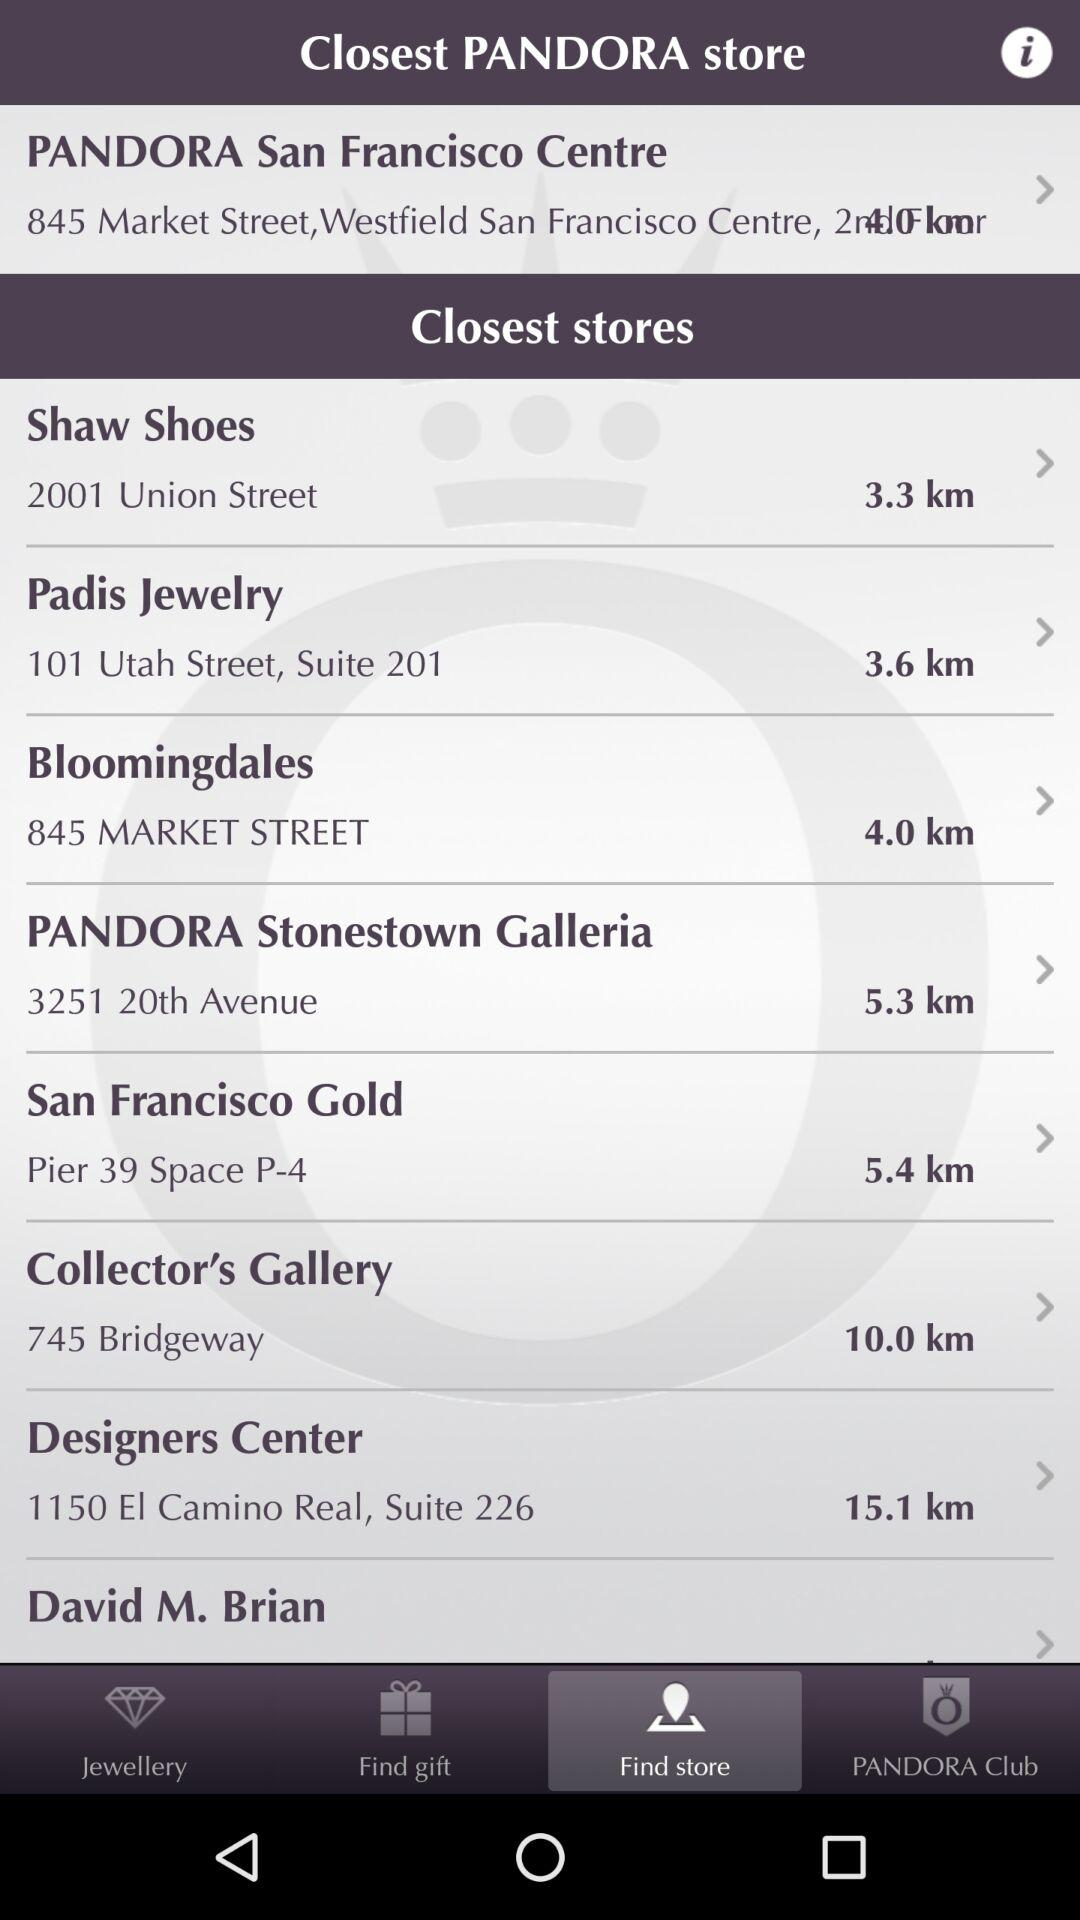What is the address of the "Designers Center"? The address of the "Designers Center" is 1150 El Camino Real, Suite 226. 